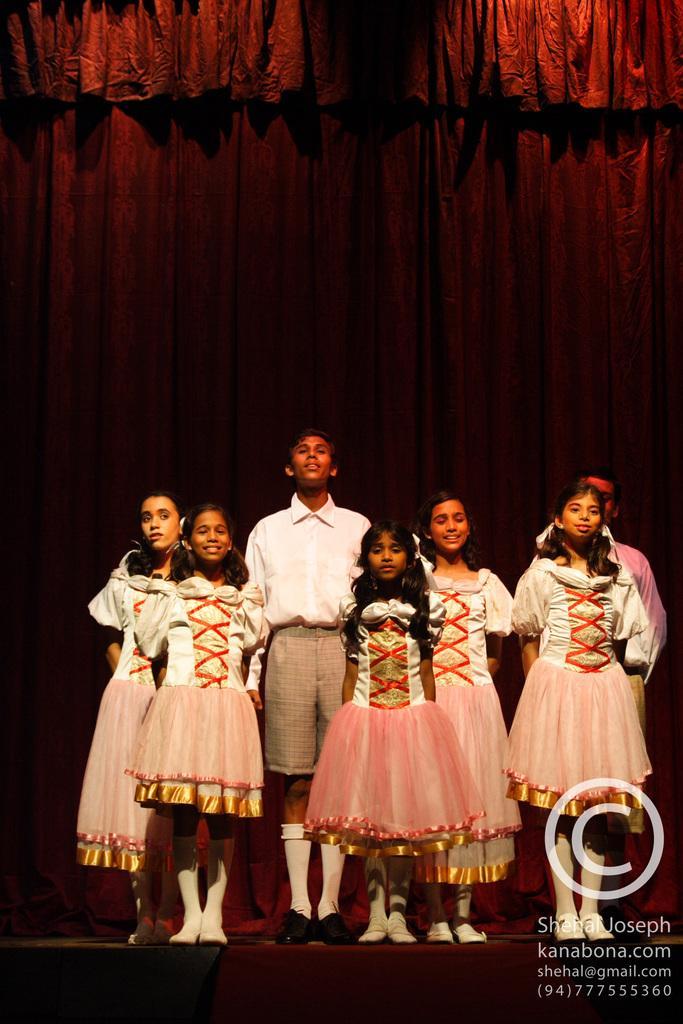Could you give a brief overview of what you see in this image? This picture is taken on a stage. On the stage, there are children wearing ancient clothes. Girls are wearing pink frocks and boys are wearing white shirt and cream shorts. In the background, there is a red curtain. 